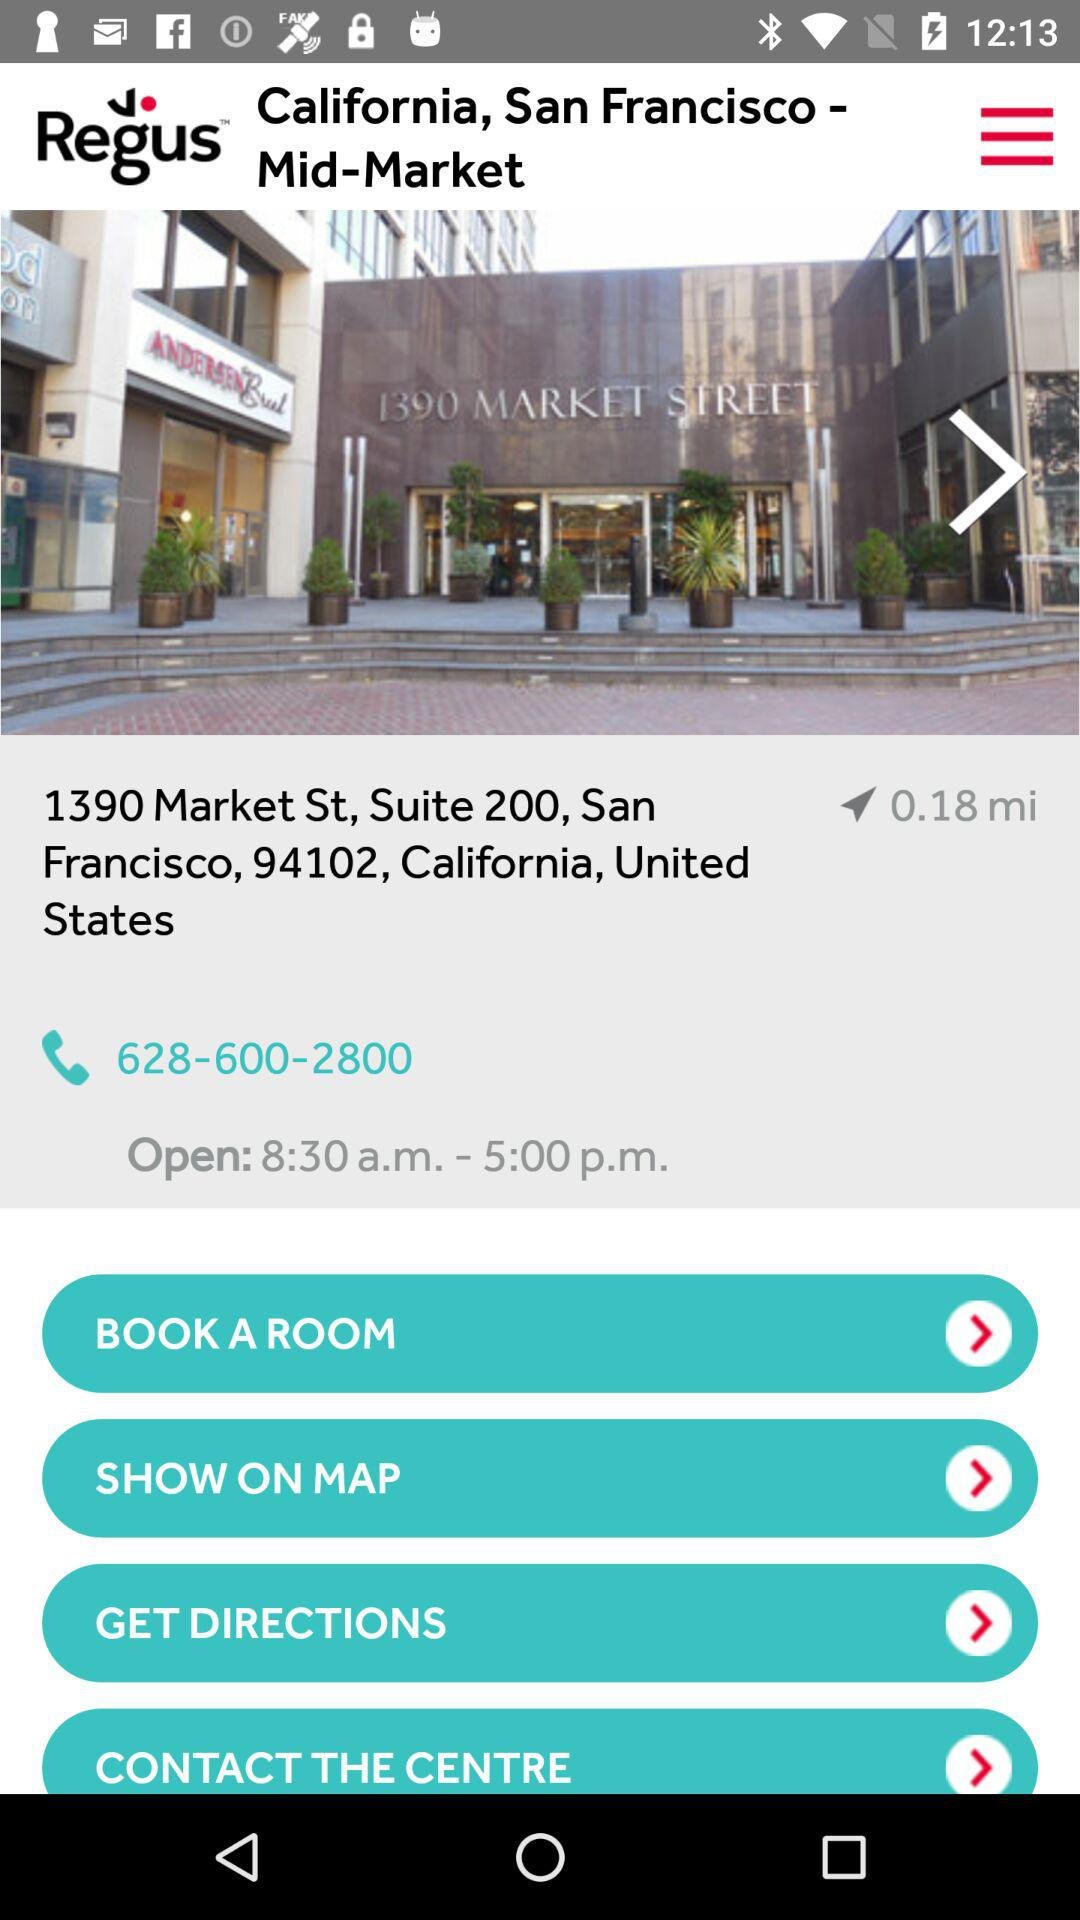How far is 1390 Market St., Suite 200, San Francisco, from my location? 1390 Market St., Suite 200, San Francisco is 0.81 miles away from your location. 